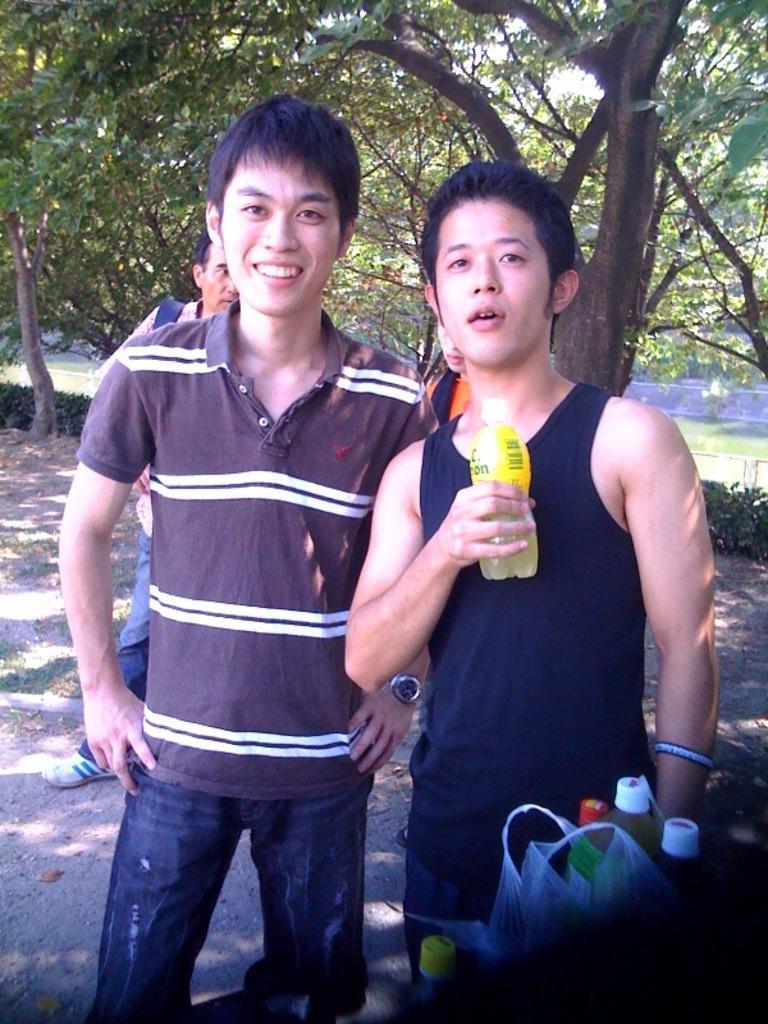How would you summarize this image in a sentence or two? In this image I see 3 men and a person over here and I see that this man is smiling and this man is holding a bottle in his hand and I see few more bottles over here and I see the path. In the background I see the plants and the trees. 